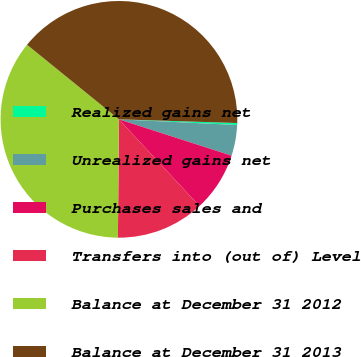<chart> <loc_0><loc_0><loc_500><loc_500><pie_chart><fcel>Realized gains net<fcel>Unrealized gains net<fcel>Purchases sales and<fcel>Transfers into (out of) Level<fcel>Balance at December 31 2012<fcel>Balance at December 31 2013<nl><fcel>0.27%<fcel>4.2%<fcel>8.12%<fcel>12.05%<fcel>35.71%<fcel>39.64%<nl></chart> 